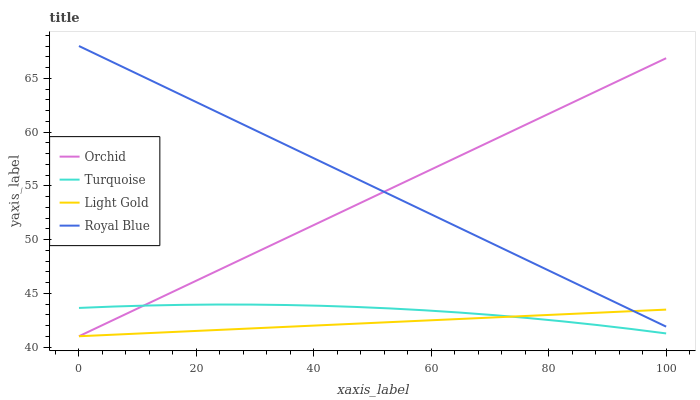Does Turquoise have the minimum area under the curve?
Answer yes or no. No. Does Turquoise have the maximum area under the curve?
Answer yes or no. No. Is Turquoise the smoothest?
Answer yes or no. No. Is Light Gold the roughest?
Answer yes or no. No. Does Turquoise have the lowest value?
Answer yes or no. No. Does Turquoise have the highest value?
Answer yes or no. No. Is Turquoise less than Royal Blue?
Answer yes or no. Yes. Is Royal Blue greater than Turquoise?
Answer yes or no. Yes. Does Turquoise intersect Royal Blue?
Answer yes or no. No. 